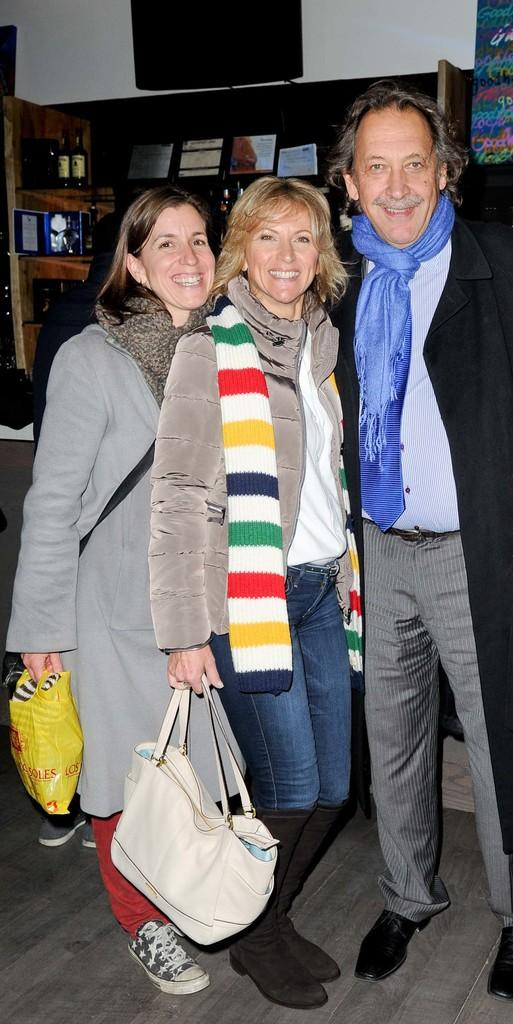How many people are in the image? There are three people in the image: one man and two women. What are the people holding in the image? The people are holding bags and plastic covers. What is the facial expression of the people in the image? The people are smiling. What can be seen in the background of the image? There are racks in the background of the image, which contain books, bottles, and papers. What is the color or texture of the wall in the background of the image? The provided facts do not mention the color or texture of the wall. Can you tell me how many squirrels are sitting on the man's shoulder in the image? There are no squirrels present in the image. What type of trick is the man performing with the porter in the image? There is no porter or trick present in the image. 